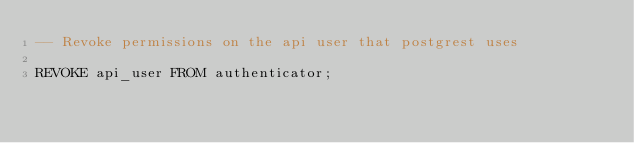<code> <loc_0><loc_0><loc_500><loc_500><_SQL_>-- Revoke permissions on the api user that postgrest uses

REVOKE api_user FROM authenticator;</code> 